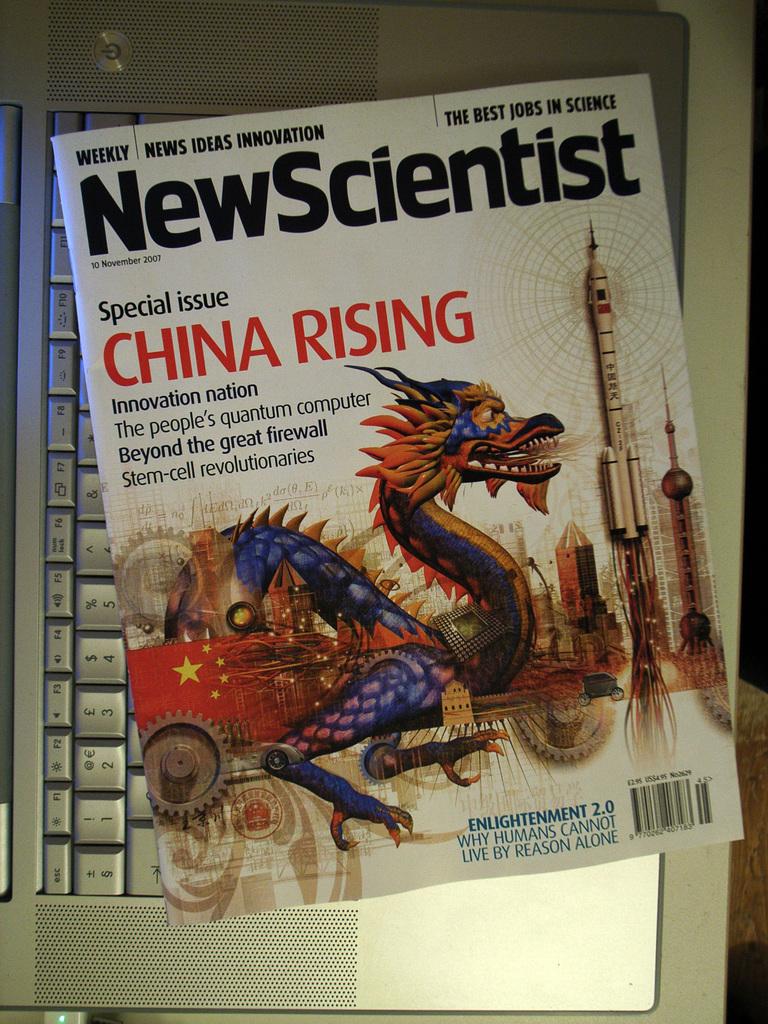What is the title of this magazine?
Keep it short and to the point. Newscientist. Who is rising?
Offer a very short reply. China. 